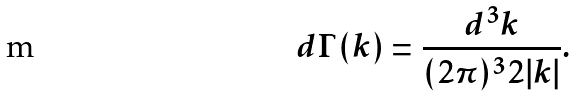Convert formula to latex. <formula><loc_0><loc_0><loc_500><loc_500>d \Gamma ( { k } ) = \frac { d ^ { 3 } k } { ( 2 \pi ) ^ { 3 } 2 | { k } | } .</formula> 